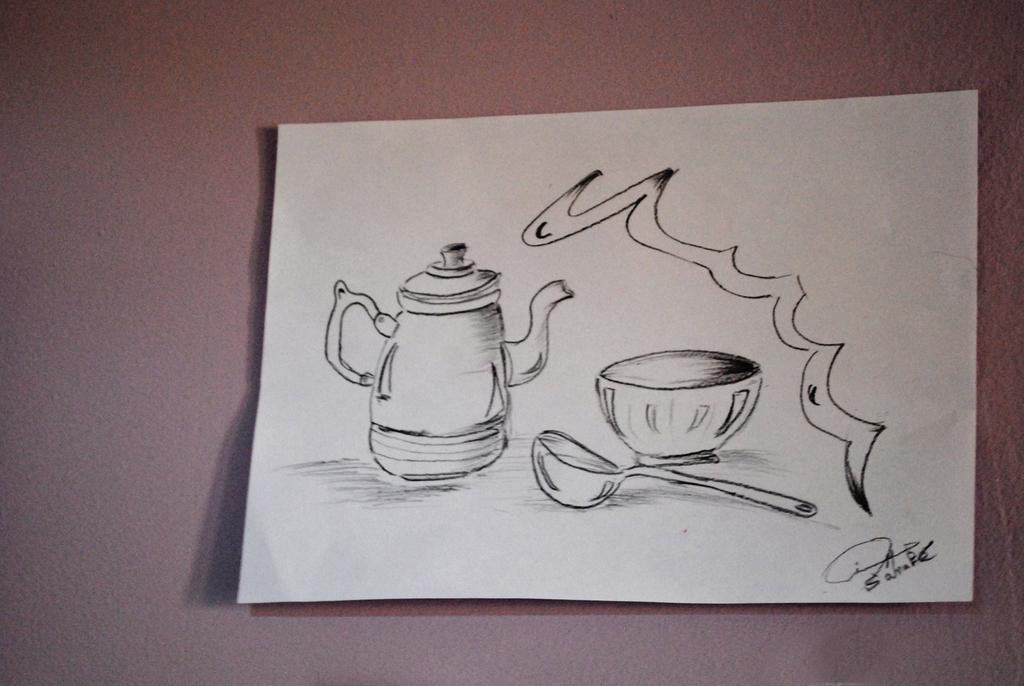Could you give a brief overview of what you see in this image? In this image there is a paper on the floor. On the paper there is painting. There is a kettle, beside there is a bowl and spoon. Right bottom of the paper there is some text. 